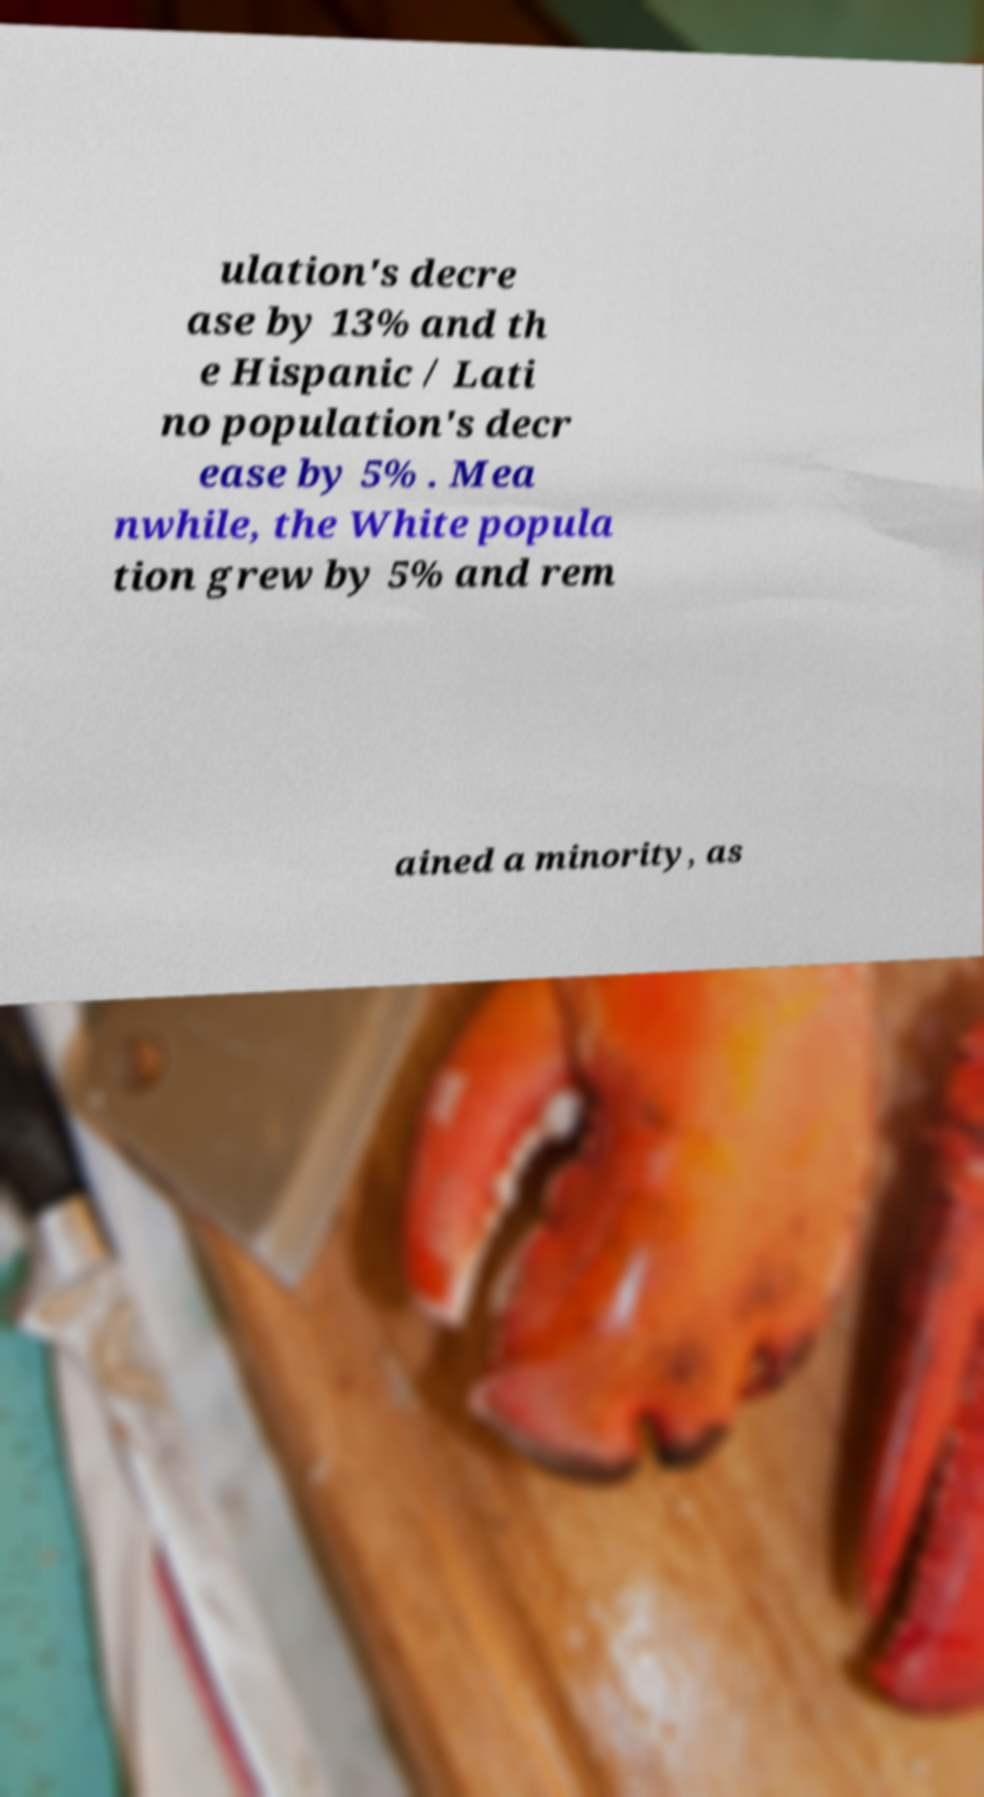Please read and relay the text visible in this image. What does it say? ulation's decre ase by 13% and th e Hispanic / Lati no population's decr ease by 5% . Mea nwhile, the White popula tion grew by 5% and rem ained a minority, as 